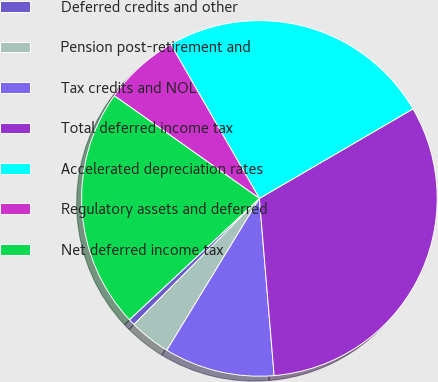Convert chart to OTSL. <chart><loc_0><loc_0><loc_500><loc_500><pie_chart><fcel>Deferred credits and other<fcel>Pension post-retirement and<fcel>Tax credits and NOL<fcel>Total deferred income tax<fcel>Accelerated depreciation rates<fcel>Regulatory assets and deferred<fcel>Net deferred income tax<nl><fcel>0.59%<fcel>3.74%<fcel>10.04%<fcel>32.08%<fcel>24.91%<fcel>6.89%<fcel>21.76%<nl></chart> 